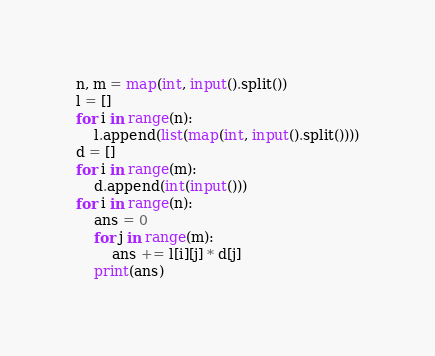<code> <loc_0><loc_0><loc_500><loc_500><_Python_>n, m = map(int, input().split())
l = []
for i in range(n):
    l.append(list(map(int, input().split())))
d = []
for i in range(m):
    d.append(int(input()))
for i in range(n):
    ans = 0
    for j in range(m):
        ans += l[i][j] * d[j]
    print(ans)
</code> 